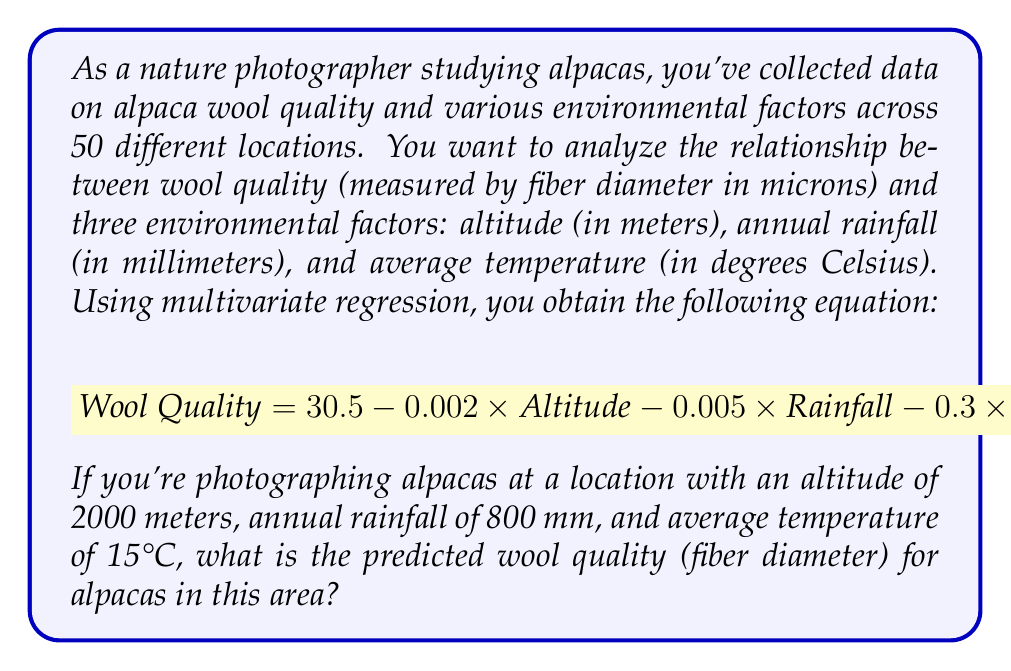What is the answer to this math problem? To solve this problem, we need to use the given multivariate regression equation and substitute the values for the environmental factors at the specific location. Let's break it down step by step:

1. The multivariate regression equation is:
   $$ \text{Wool Quality} = 30.5 - 0.002 \times \text{Altitude} - 0.005 \times \text{Rainfall} - 0.3 \times \text{Temperature} $$

2. We have the following values for the environmental factors:
   - Altitude = 2000 meters
   - Rainfall = 800 mm
   - Temperature = 15°C

3. Let's substitute these values into the equation:
   $$ \text{Wool Quality} = 30.5 - 0.002 \times 2000 - 0.005 \times 800 - 0.3 \times 15 $$

4. Now, let's calculate each term:
   - $30.5$ (constant term)
   - $-0.002 \times 2000 = -4$
   - $-0.005 \times 800 = -4$
   - $-0.3 \times 15 = -4.5$

5. Sum up all the terms:
   $$ \text{Wool Quality} = 30.5 - 4 - 4 - 4.5 = 18 $$

Therefore, the predicted wool quality (fiber diameter) for alpacas in this location is 18 microns.
Answer: 18 microns 